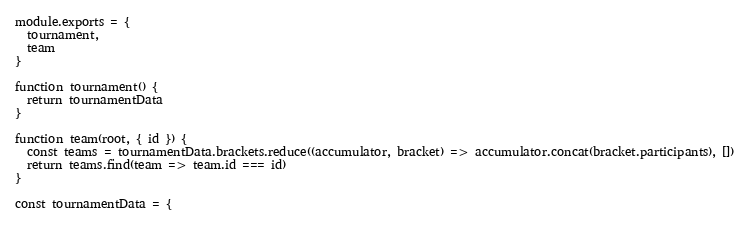Convert code to text. <code><loc_0><loc_0><loc_500><loc_500><_JavaScript_>module.exports = {
  tournament,
  team
}

function tournament() {
  return tournamentData
}

function team(root, { id }) {
  const teams = tournamentData.brackets.reduce((accumulator, bracket) => accumulator.concat(bracket.participants), [])
  return teams.find(team => team.id === id)
}

const tournamentData = {</code> 